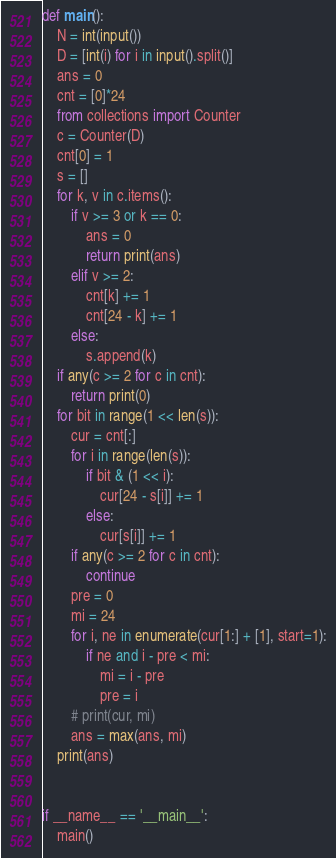<code> <loc_0><loc_0><loc_500><loc_500><_Python_>def main():
    N = int(input())
    D = [int(i) for i in input().split()]
    ans = 0
    cnt = [0]*24
    from collections import Counter
    c = Counter(D)
    cnt[0] = 1
    s = []
    for k, v in c.items():
        if v >= 3 or k == 0:
            ans = 0
            return print(ans)
        elif v >= 2:
            cnt[k] += 1
            cnt[24 - k] += 1
        else:
            s.append(k)
    if any(c >= 2 for c in cnt):
        return print(0)
    for bit in range(1 << len(s)):
        cur = cnt[:]
        for i in range(len(s)):
            if bit & (1 << i):
                cur[24 - s[i]] += 1
            else:
                cur[s[i]] += 1
        if any(c >= 2 for c in cnt):
            continue
        pre = 0
        mi = 24
        for i, ne in enumerate(cur[1:] + [1], start=1):
            if ne and i - pre < mi:
                mi = i - pre
                pre = i
        # print(cur, mi)
        ans = max(ans, mi)
    print(ans)


if __name__ == '__main__':
    main()
</code> 